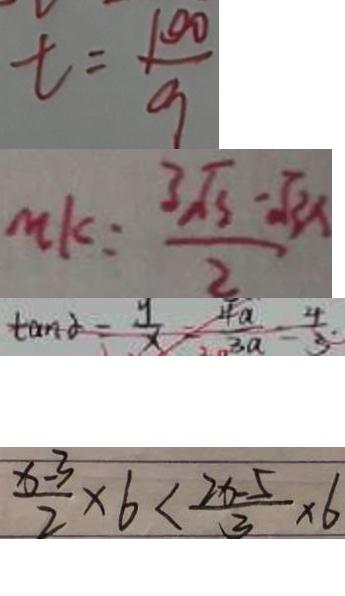Convert formula to latex. <formula><loc_0><loc_0><loc_500><loc_500>t = \frac { 1 0 0 } { 9 } 
 m k = \frac { 3 \sqrt { 3 } - \sqrt { 3 x } } { 2 } 
 \tan \alpha = \frac { y } { x } - \frac { 4 a } { 3 a } = \frac { 4 } { 3 } 
 \frac { x - 3 } { 2 } \times 6 < \frac { 2 x - 5 } { 3 } \times 6</formula> 